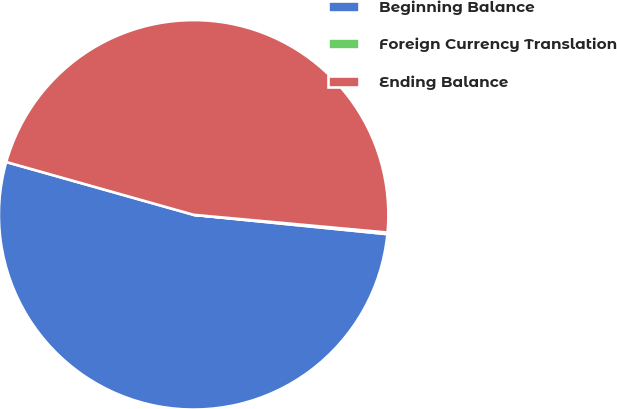Convert chart to OTSL. <chart><loc_0><loc_0><loc_500><loc_500><pie_chart><fcel>Beginning Balance<fcel>Foreign Currency Translation<fcel>Ending Balance<nl><fcel>52.79%<fcel>0.13%<fcel>47.08%<nl></chart> 